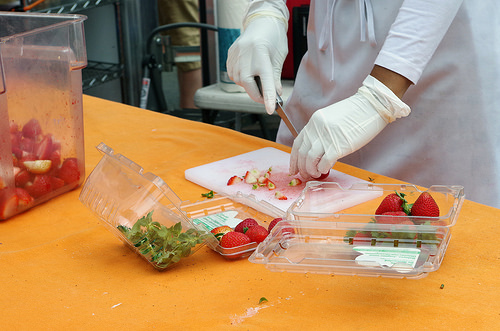<image>
Can you confirm if the strawberry is under the strawberry? Yes. The strawberry is positioned underneath the strawberry, with the strawberry above it in the vertical space. Is there a knife in the box? No. The knife is not contained within the box. These objects have a different spatial relationship. 